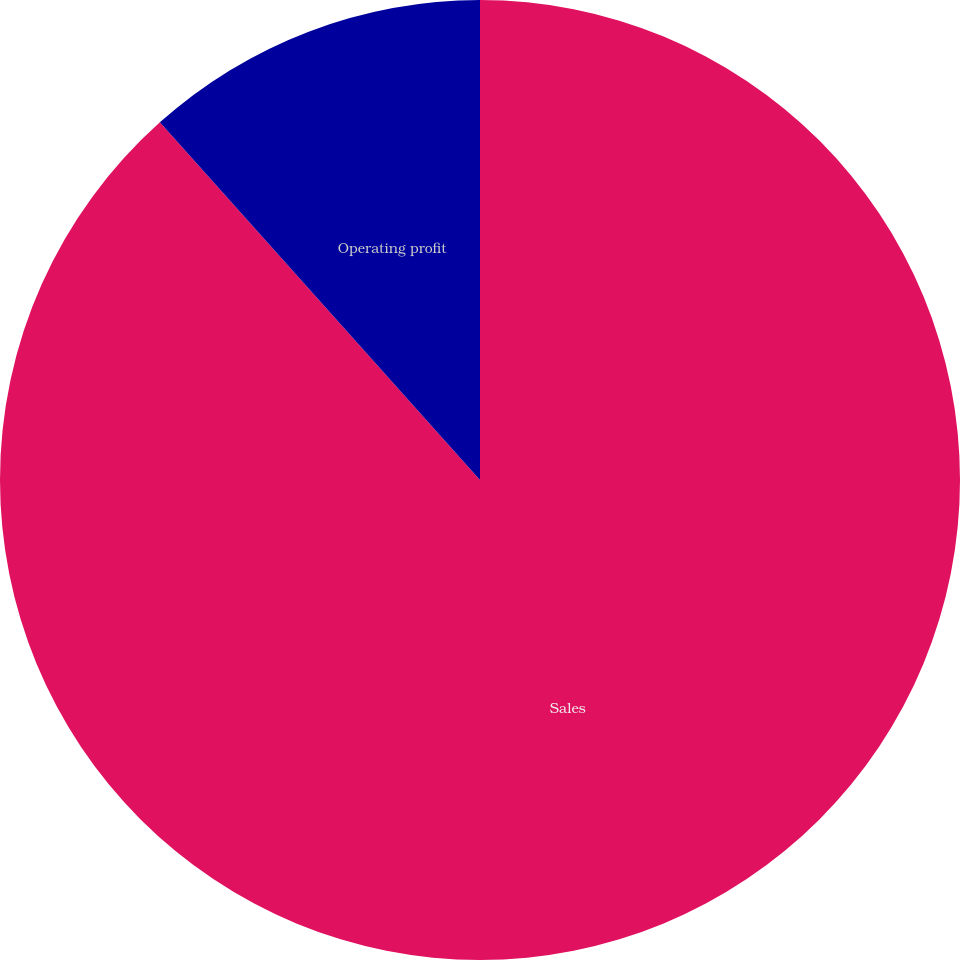Convert chart. <chart><loc_0><loc_0><loc_500><loc_500><pie_chart><fcel>Sales<fcel>Operating profit<nl><fcel>88.38%<fcel>11.62%<nl></chart> 